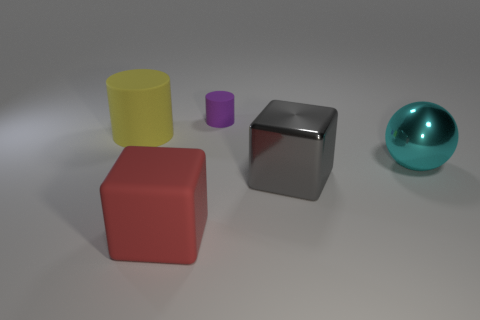Add 3 tiny green metal cylinders. How many objects exist? 8 Subtract all cubes. How many objects are left? 3 Subtract all large cyan matte cylinders. Subtract all purple rubber things. How many objects are left? 4 Add 2 red objects. How many red objects are left? 3 Add 5 yellow cylinders. How many yellow cylinders exist? 6 Subtract 1 cyan balls. How many objects are left? 4 